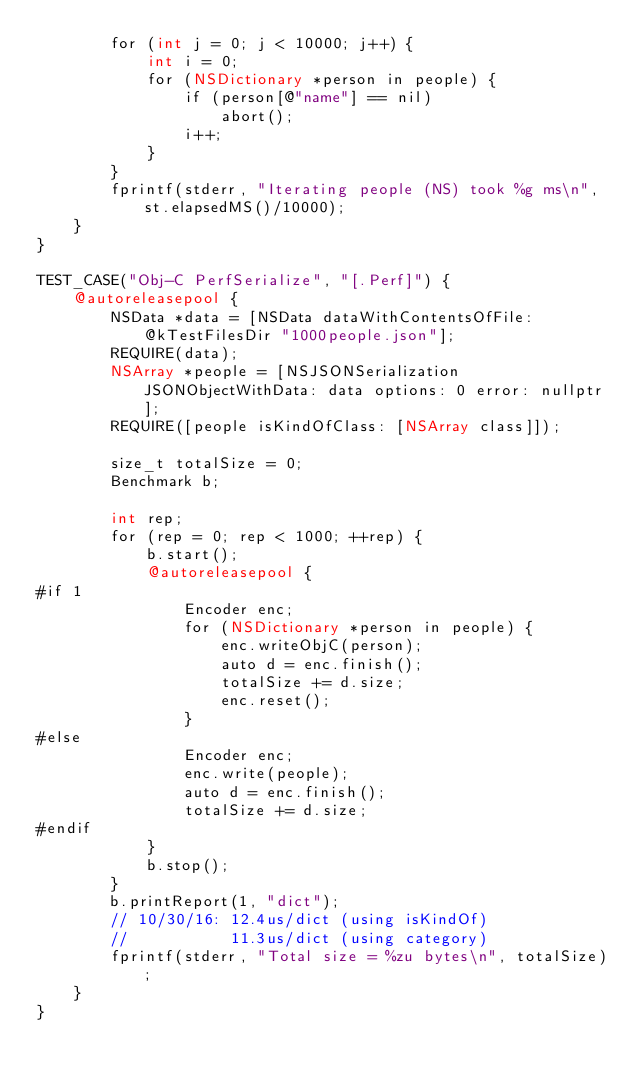<code> <loc_0><loc_0><loc_500><loc_500><_ObjectiveC_>        for (int j = 0; j < 10000; j++) {
            int i = 0;
            for (NSDictionary *person in people) {
                if (person[@"name"] == nil)
                    abort();
                i++;
            }
        }
        fprintf(stderr, "Iterating people (NS) took %g ms\n", st.elapsedMS()/10000);
    }
}

TEST_CASE("Obj-C PerfSerialize", "[.Perf]") {
    @autoreleasepool {
        NSData *data = [NSData dataWithContentsOfFile: @kTestFilesDir "1000people.json"];
        REQUIRE(data);
        NSArray *people = [NSJSONSerialization JSONObjectWithData: data options: 0 error: nullptr];
        REQUIRE([people isKindOfClass: [NSArray class]]);

        size_t totalSize = 0;
        Benchmark b;

        int rep;
        for (rep = 0; rep < 1000; ++rep) {
            b.start();
            @autoreleasepool {
#if 1
                Encoder enc;
                for (NSDictionary *person in people) {
                    enc.writeObjC(person);
                    auto d = enc.finish();
                    totalSize += d.size;
                    enc.reset();
                }
#else
                Encoder enc;
                enc.write(people);
                auto d = enc.finish();
                totalSize += d.size;
#endif
            }
            b.stop();
        }
        b.printReport(1, "dict");
        // 10/30/16: 12.4us/dict (using isKindOf)
        //           11.3us/dict (using category)
        fprintf(stderr, "Total size = %zu bytes\n", totalSize);
    }
}
</code> 